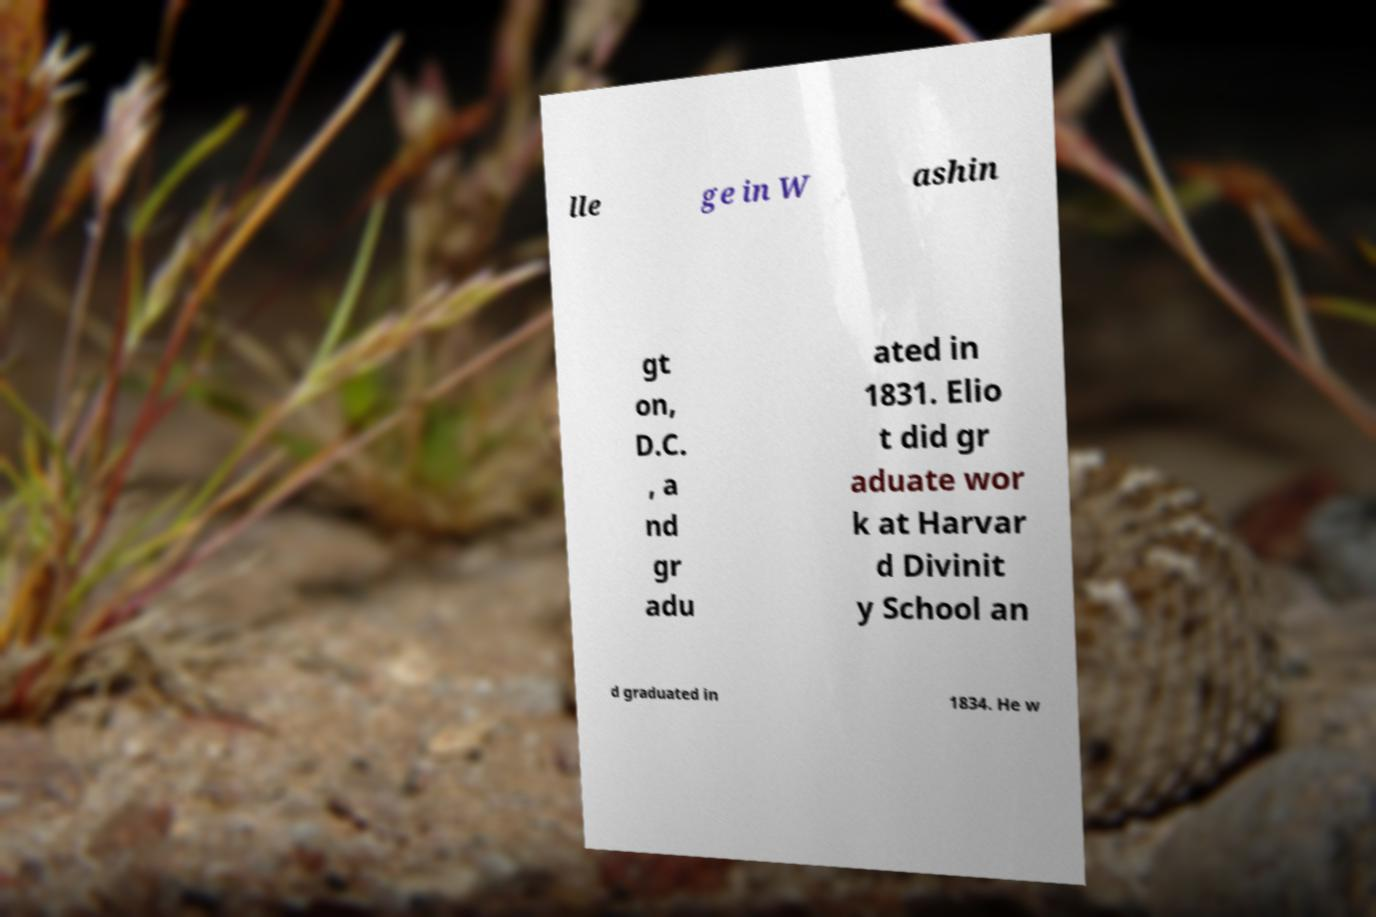Please read and relay the text visible in this image. What does it say? lle ge in W ashin gt on, D.C. , a nd gr adu ated in 1831. Elio t did gr aduate wor k at Harvar d Divinit y School an d graduated in 1834. He w 